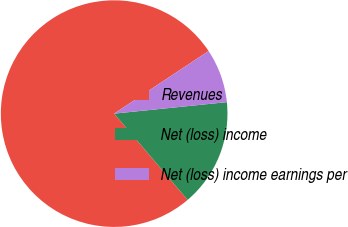Convert chart to OTSL. <chart><loc_0><loc_0><loc_500><loc_500><pie_chart><fcel>Revenues<fcel>Net (loss) income<fcel>Net (loss) income earnings per<nl><fcel>76.92%<fcel>15.39%<fcel>7.7%<nl></chart> 